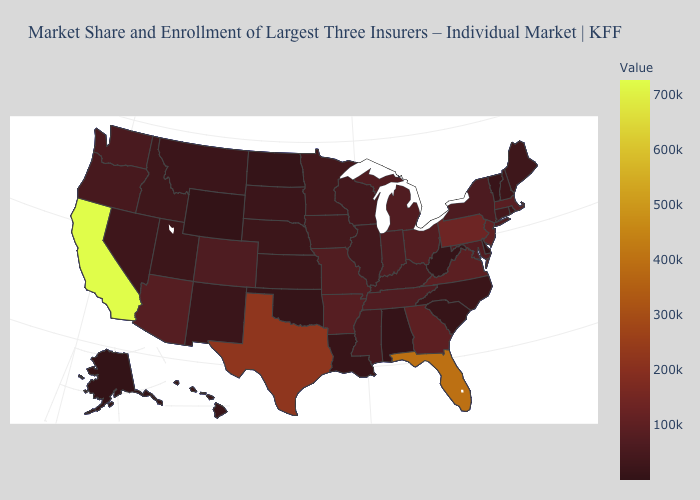Among the states that border New Hampshire , which have the lowest value?
Be succinct. Vermont. Which states have the lowest value in the USA?
Quick response, please. Alaska. Which states have the lowest value in the USA?
Quick response, please. Alaska. Does Indiana have the highest value in the USA?
Quick response, please. No. Which states have the lowest value in the USA?
Quick response, please. Alaska. Among the states that border Washington , does Idaho have the highest value?
Short answer required. No. 